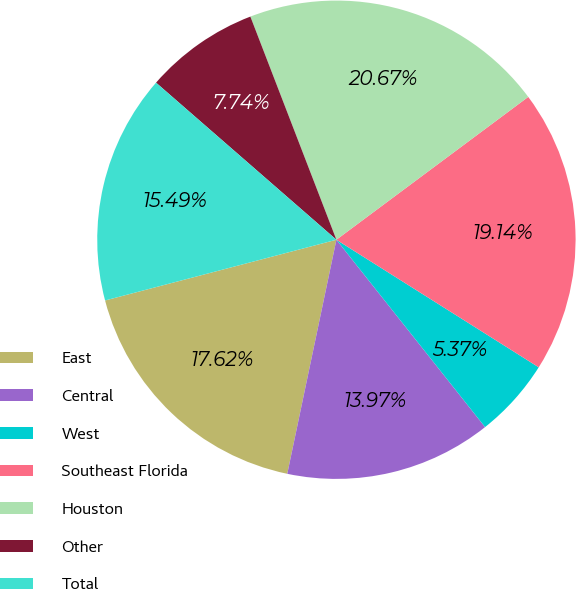Convert chart. <chart><loc_0><loc_0><loc_500><loc_500><pie_chart><fcel>East<fcel>Central<fcel>West<fcel>Southeast Florida<fcel>Houston<fcel>Other<fcel>Total<nl><fcel>17.62%<fcel>13.97%<fcel>5.37%<fcel>19.14%<fcel>20.67%<fcel>7.74%<fcel>15.49%<nl></chart> 